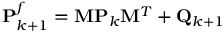<formula> <loc_0><loc_0><loc_500><loc_500>P _ { k + 1 } ^ { f } = M P _ { k } M ^ { T } + Q _ { k + 1 }</formula> 